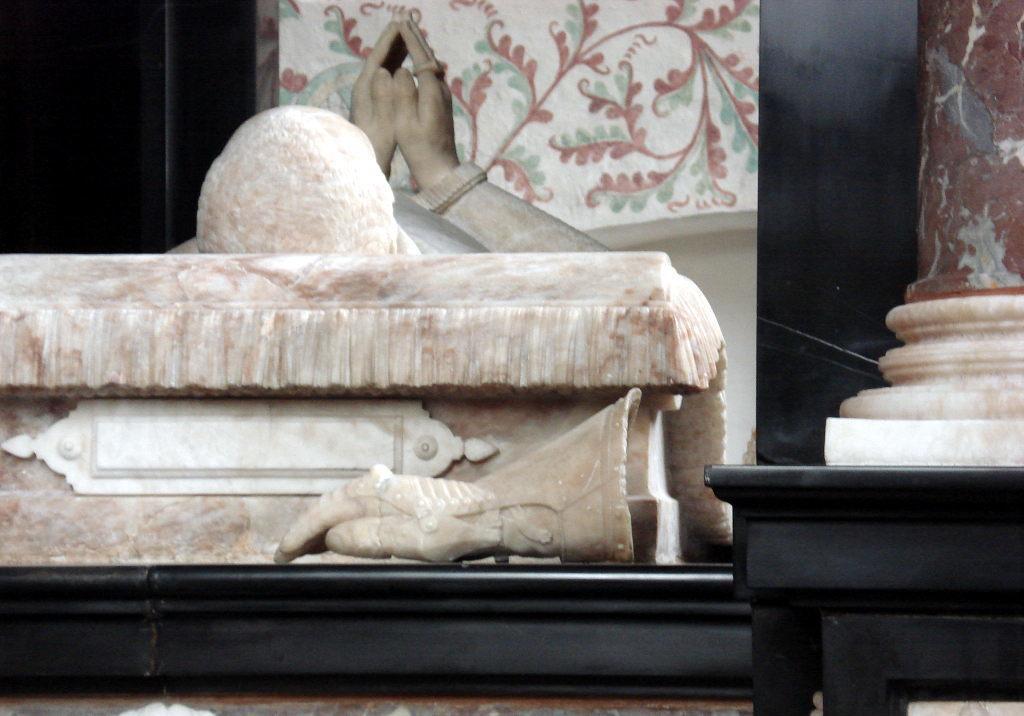Please provide a concise description of this image. In this image I can see a statue and a depiction of a hand in the centre of this image. 